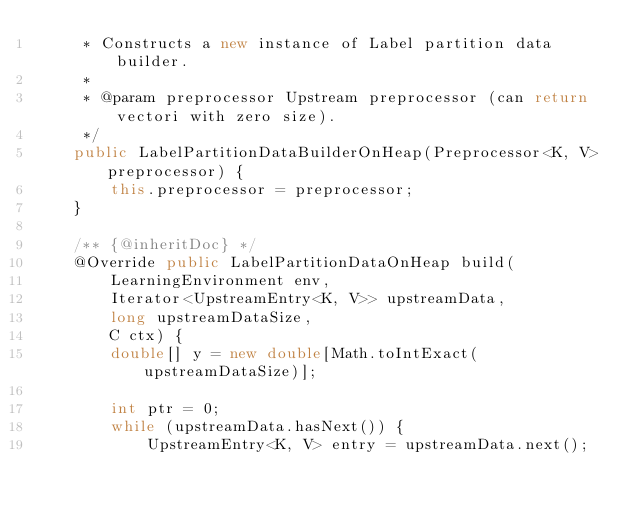Convert code to text. <code><loc_0><loc_0><loc_500><loc_500><_Java_>     * Constructs a new instance of Label partition data builder.
     *
     * @param preprocessor Upstream preprocessor (can return vectori with zero size).
     */
    public LabelPartitionDataBuilderOnHeap(Preprocessor<K, V> preprocessor) {
        this.preprocessor = preprocessor;
    }

    /** {@inheritDoc} */
    @Override public LabelPartitionDataOnHeap build(
        LearningEnvironment env,
        Iterator<UpstreamEntry<K, V>> upstreamData,
        long upstreamDataSize,
        C ctx) {
        double[] y = new double[Math.toIntExact(upstreamDataSize)];

        int ptr = 0;
        while (upstreamData.hasNext()) {
            UpstreamEntry<K, V> entry = upstreamData.next();
</code> 